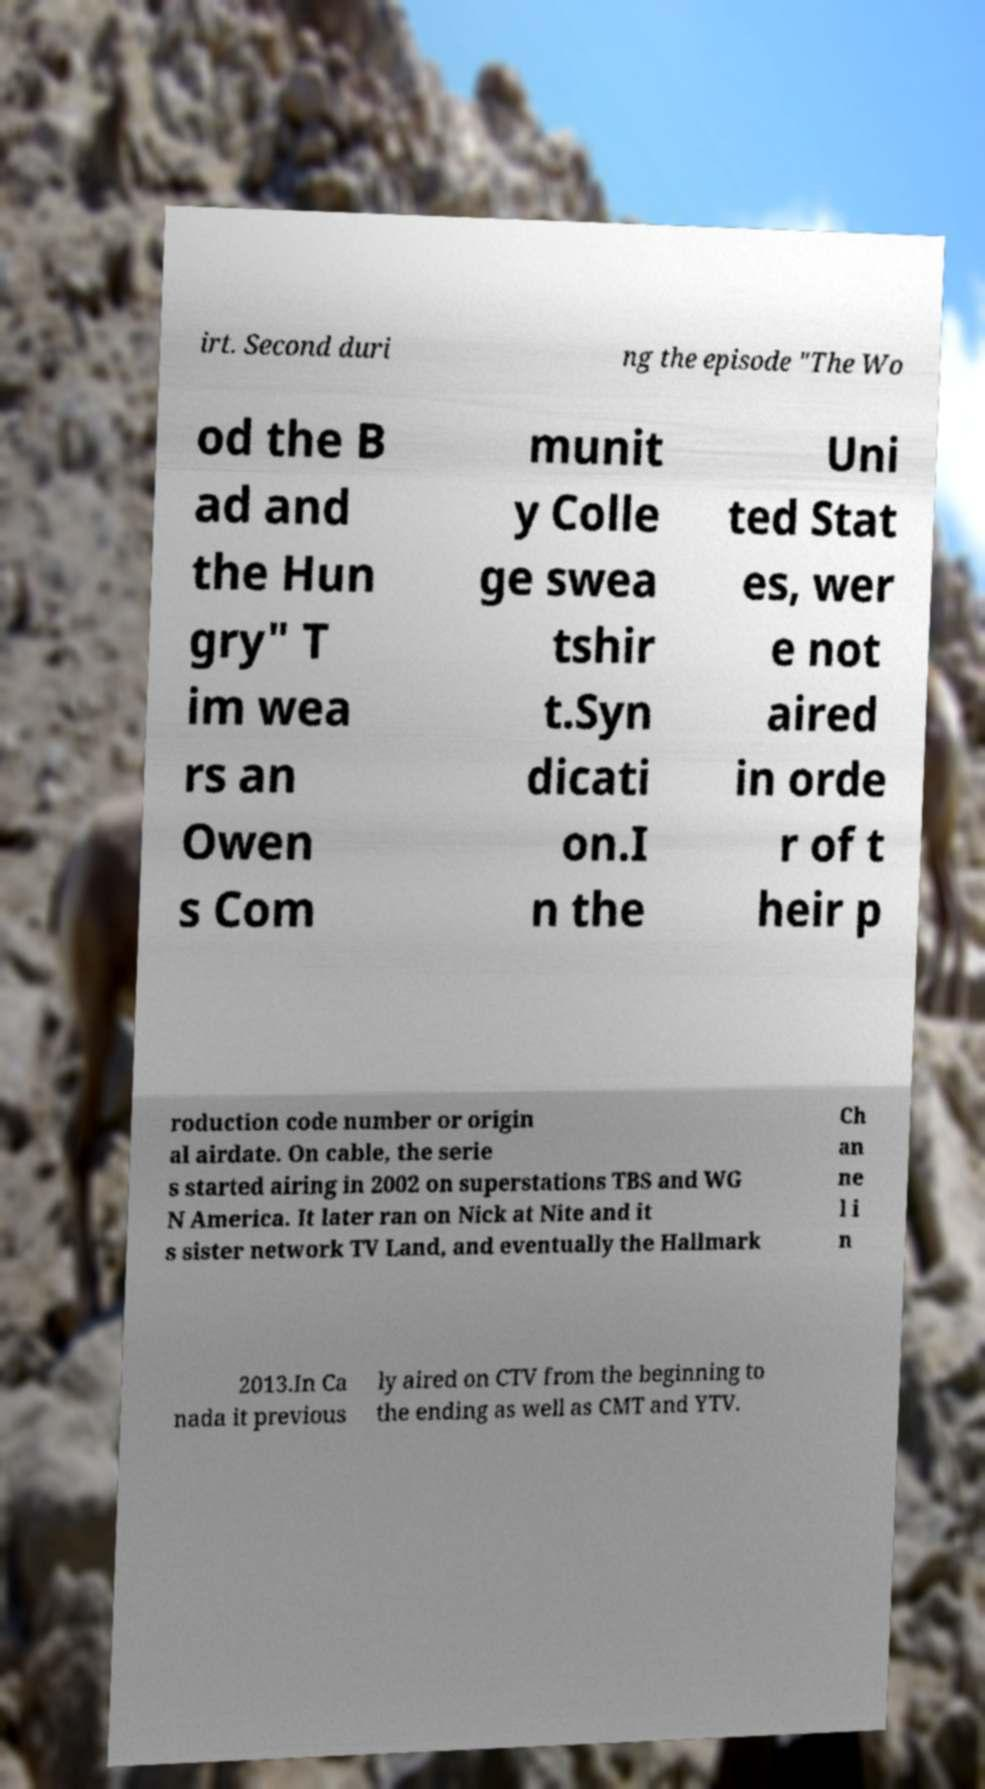Could you assist in decoding the text presented in this image and type it out clearly? irt. Second duri ng the episode "The Wo od the B ad and the Hun gry" T im wea rs an Owen s Com munit y Colle ge swea tshir t.Syn dicati on.I n the Uni ted Stat es, wer e not aired in orde r of t heir p roduction code number or origin al airdate. On cable, the serie s started airing in 2002 on superstations TBS and WG N America. It later ran on Nick at Nite and it s sister network TV Land, and eventually the Hallmark Ch an ne l i n 2013.In Ca nada it previous ly aired on CTV from the beginning to the ending as well as CMT and YTV. 